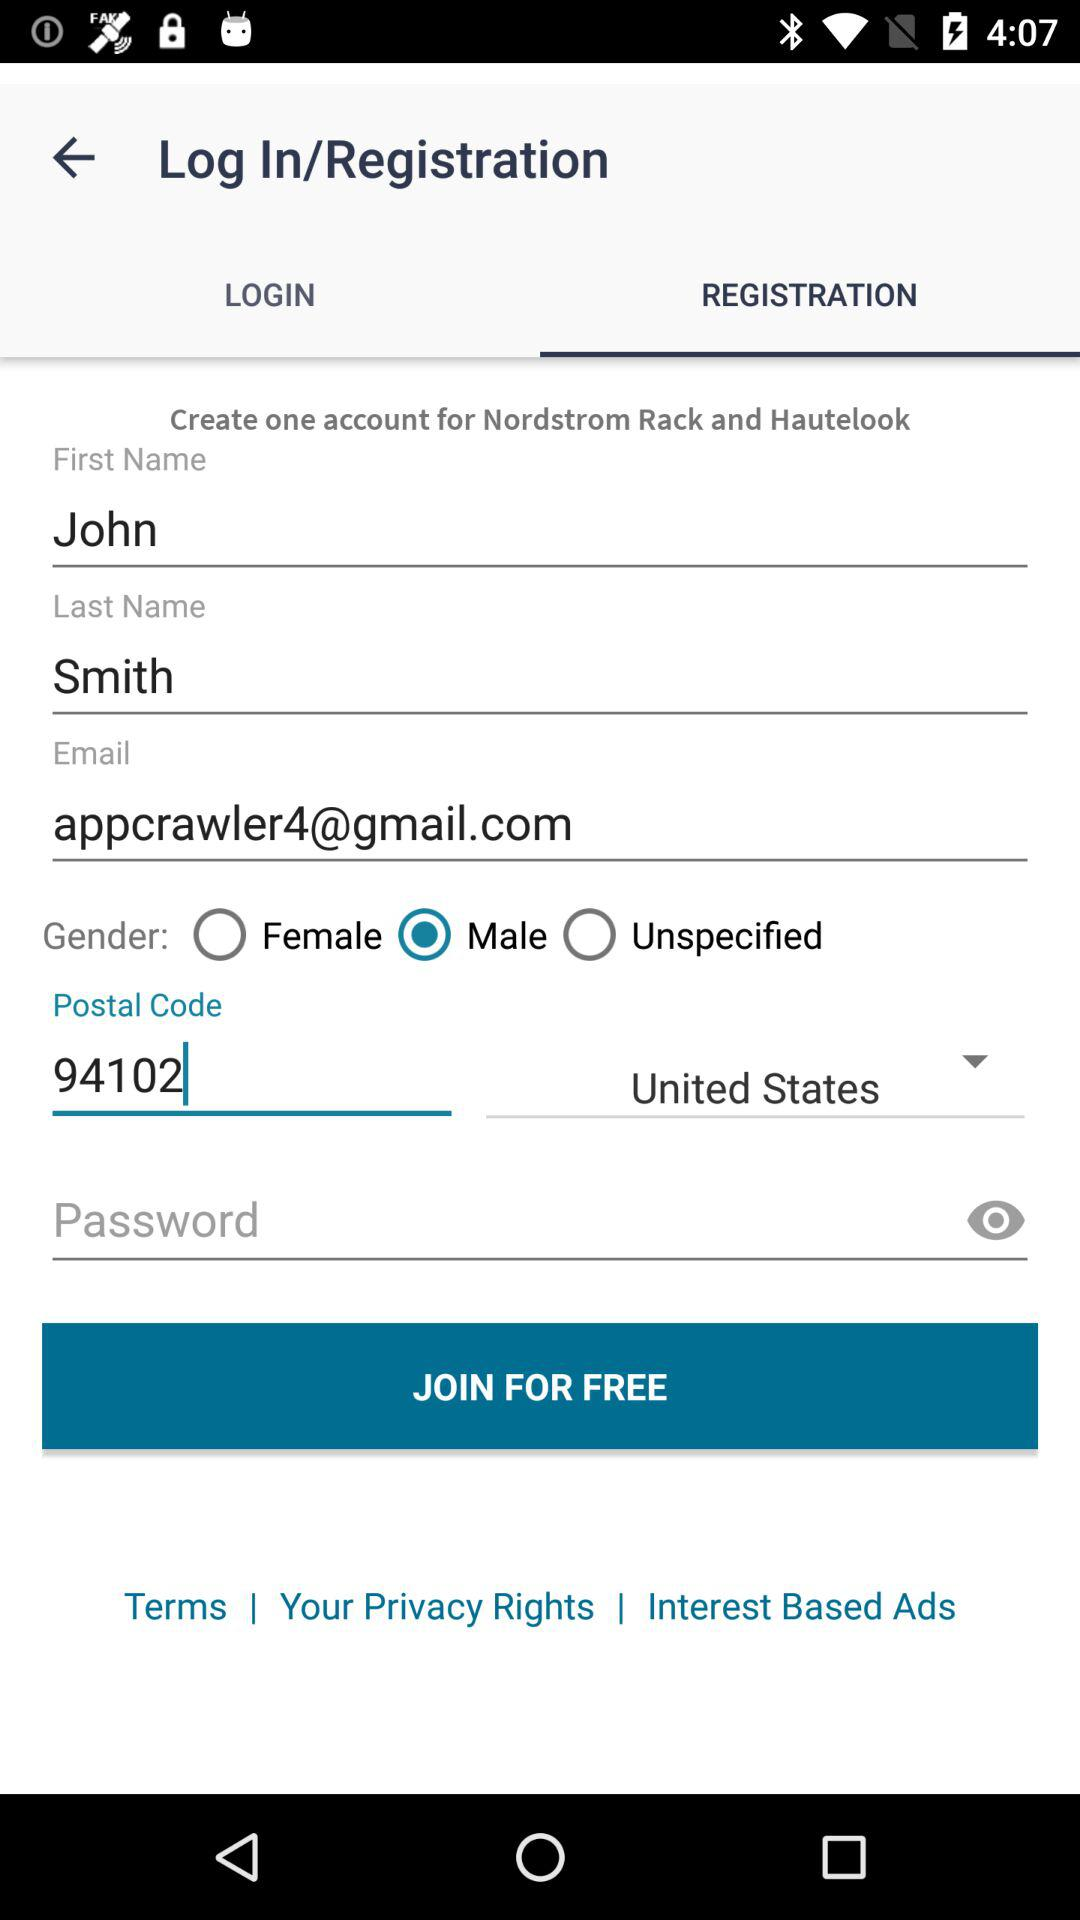Which tab is selected? The selected tab is "REGISTRATION". 